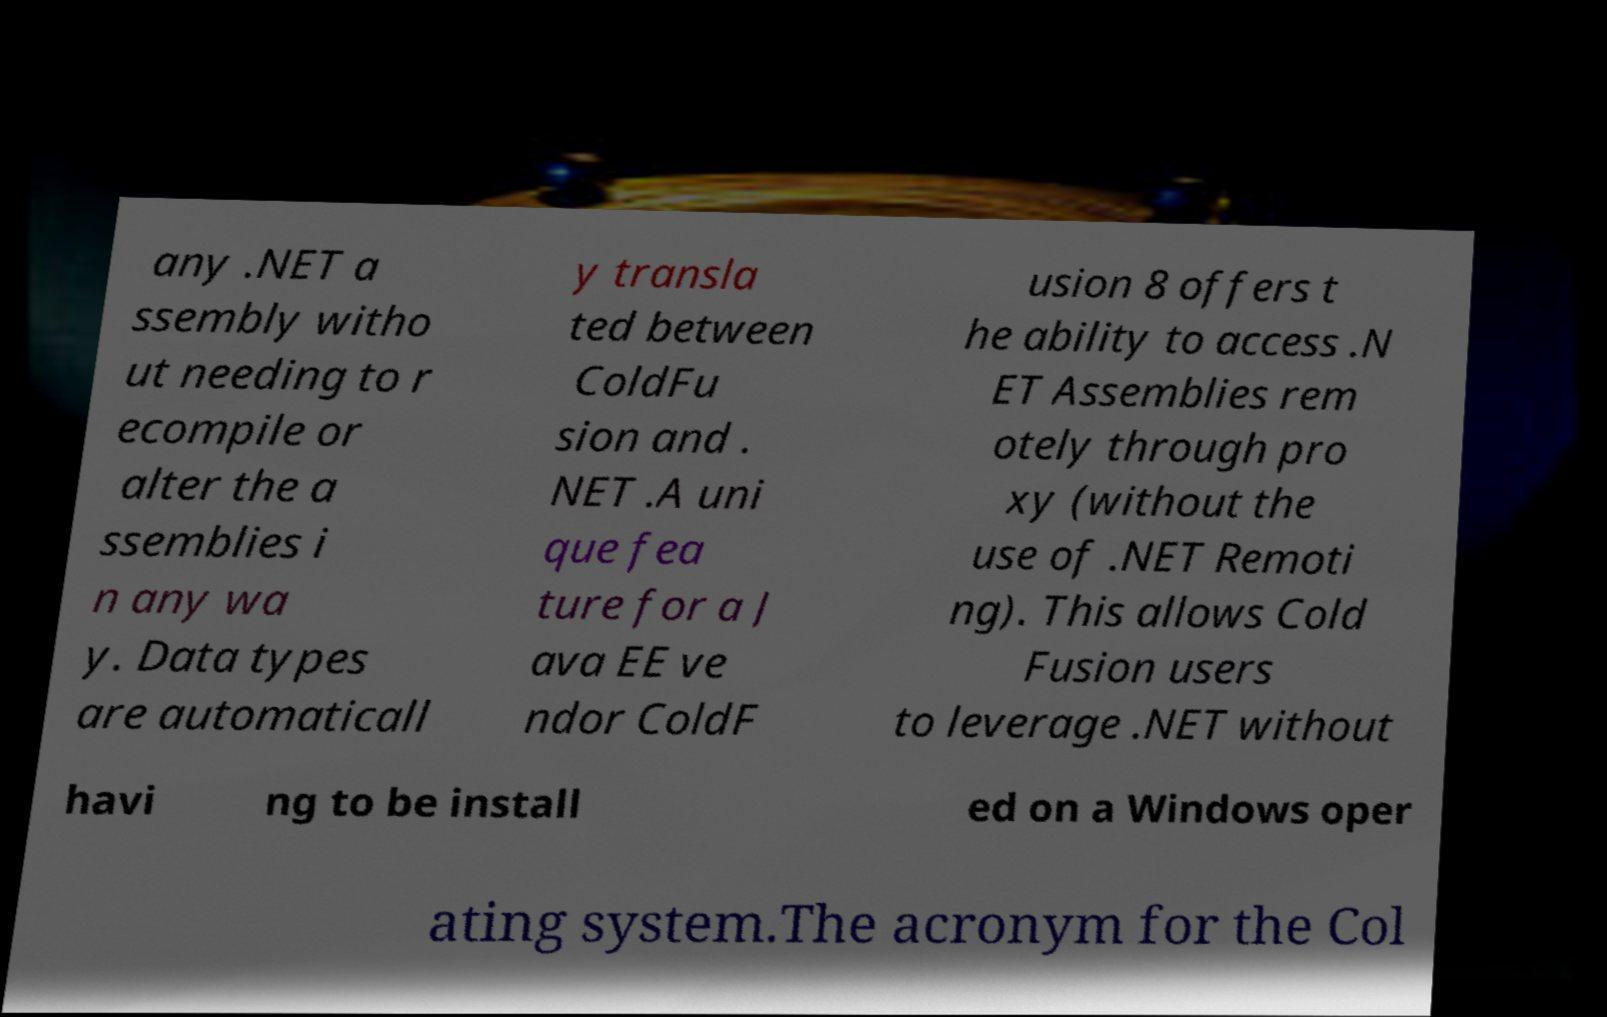For documentation purposes, I need the text within this image transcribed. Could you provide that? any .NET a ssembly witho ut needing to r ecompile or alter the a ssemblies i n any wa y. Data types are automaticall y transla ted between ColdFu sion and . NET .A uni que fea ture for a J ava EE ve ndor ColdF usion 8 offers t he ability to access .N ET Assemblies rem otely through pro xy (without the use of .NET Remoti ng). This allows Cold Fusion users to leverage .NET without havi ng to be install ed on a Windows oper ating system.The acronym for the Col 